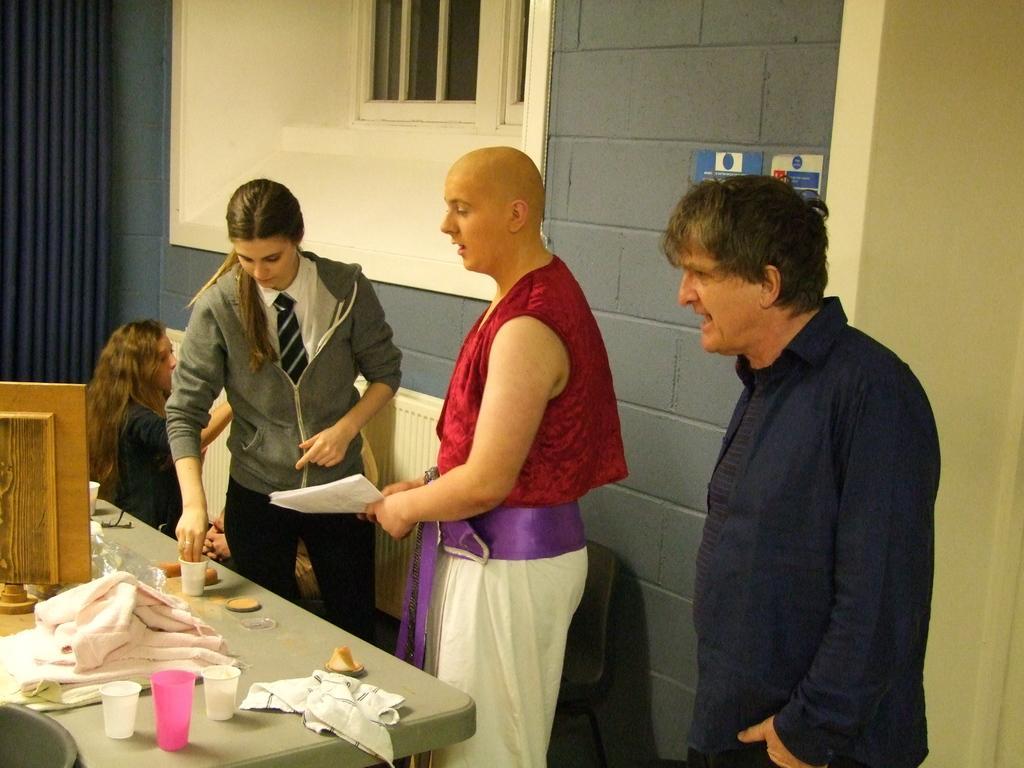Please provide a concise description of this image. In this i can see a curtain on the left side and i can see a wall ,on the wall there is a window and i can see a table ,on the table there are the some glasses and clothes. And a woman put her hand on the glass. And i can a person on the right side wearing a black color jacket and i can a person wearing a red color jacket on the middle , his holding a paper on his hand. 